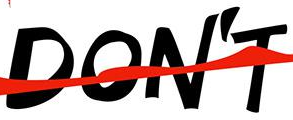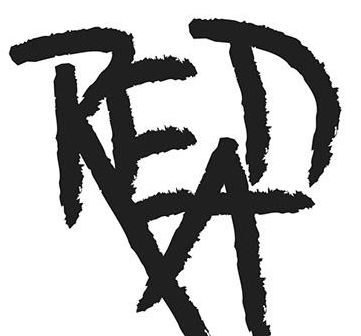What text appears in these images from left to right, separated by a semicolon? DON'T; READ 